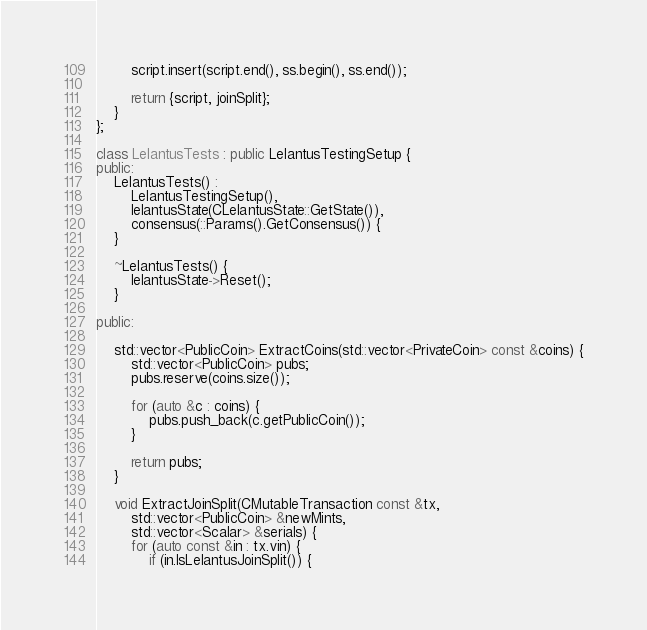Convert code to text. <code><loc_0><loc_0><loc_500><loc_500><_C++_>        script.insert(script.end(), ss.begin(), ss.end());

        return {script, joinSplit};
    }
};

class LelantusTests : public LelantusTestingSetup {
public:
    LelantusTests() :
        LelantusTestingSetup(),
        lelantusState(CLelantusState::GetState()),
        consensus(::Params().GetConsensus()) {
    }

    ~LelantusTests() {
        lelantusState->Reset();
    }

public:

    std::vector<PublicCoin> ExtractCoins(std::vector<PrivateCoin> const &coins) {
        std::vector<PublicCoin> pubs;
        pubs.reserve(coins.size());

        for (auto &c : coins) {
            pubs.push_back(c.getPublicCoin());
        }

        return pubs;
    }

    void ExtractJoinSplit(CMutableTransaction const &tx,
        std::vector<PublicCoin> &newMints,
        std::vector<Scalar> &serials) {
        for (auto const &in : tx.vin) {
            if (in.IsLelantusJoinSplit()) {</code> 